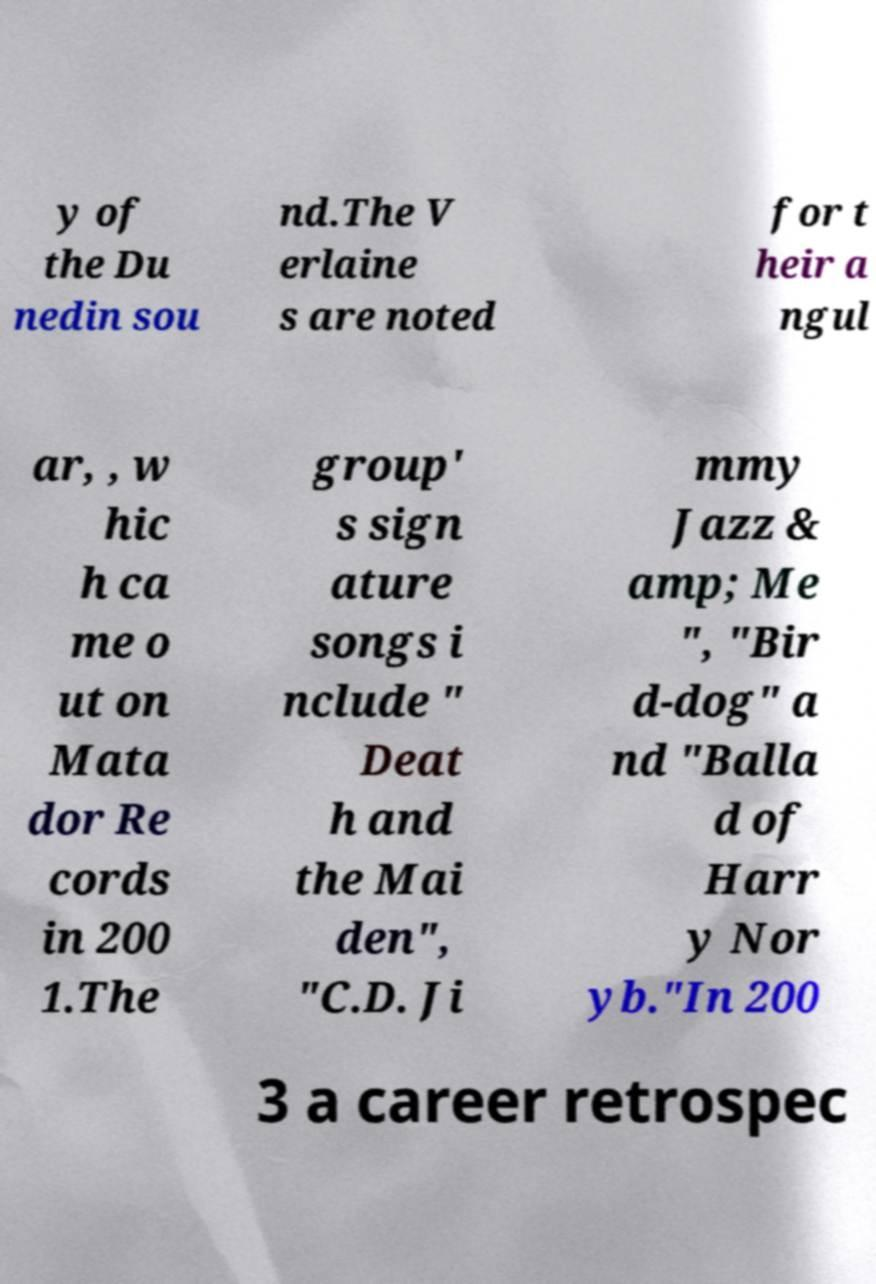Please read and relay the text visible in this image. What does it say? y of the Du nedin sou nd.The V erlaine s are noted for t heir a ngul ar, , w hic h ca me o ut on Mata dor Re cords in 200 1.The group' s sign ature songs i nclude " Deat h and the Mai den", "C.D. Ji mmy Jazz & amp; Me ", "Bir d-dog" a nd "Balla d of Harr y Nor yb."In 200 3 a career retrospec 